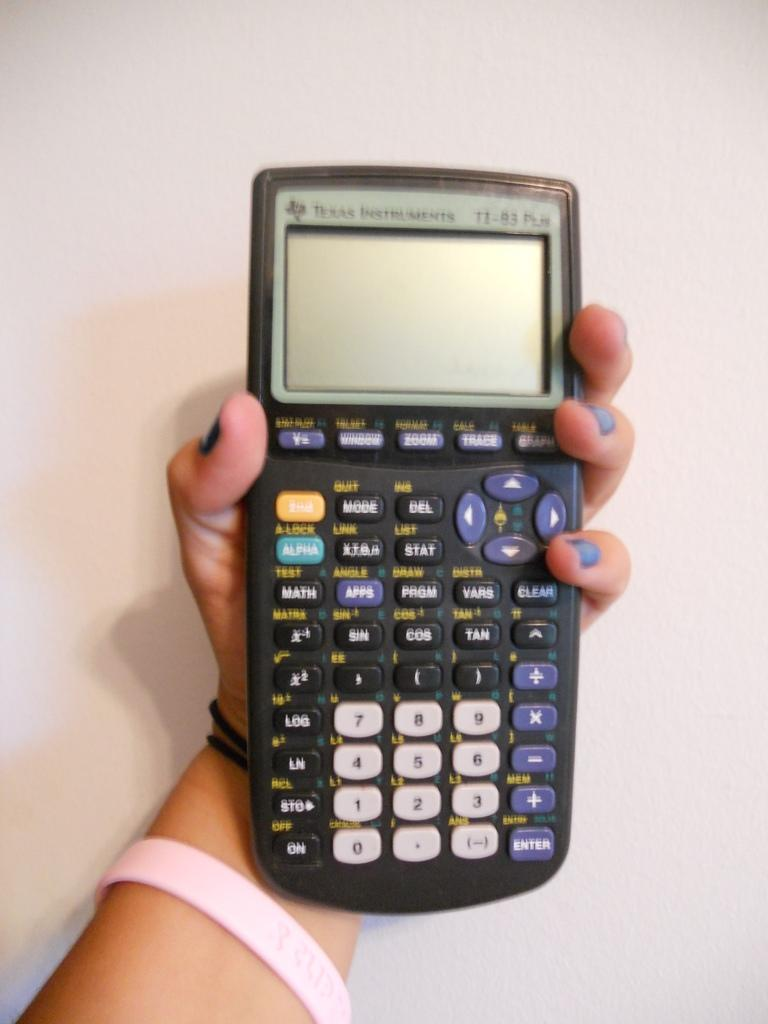<image>
Relay a brief, clear account of the picture shown. Person holding a calculator that says Texas Instruments. 